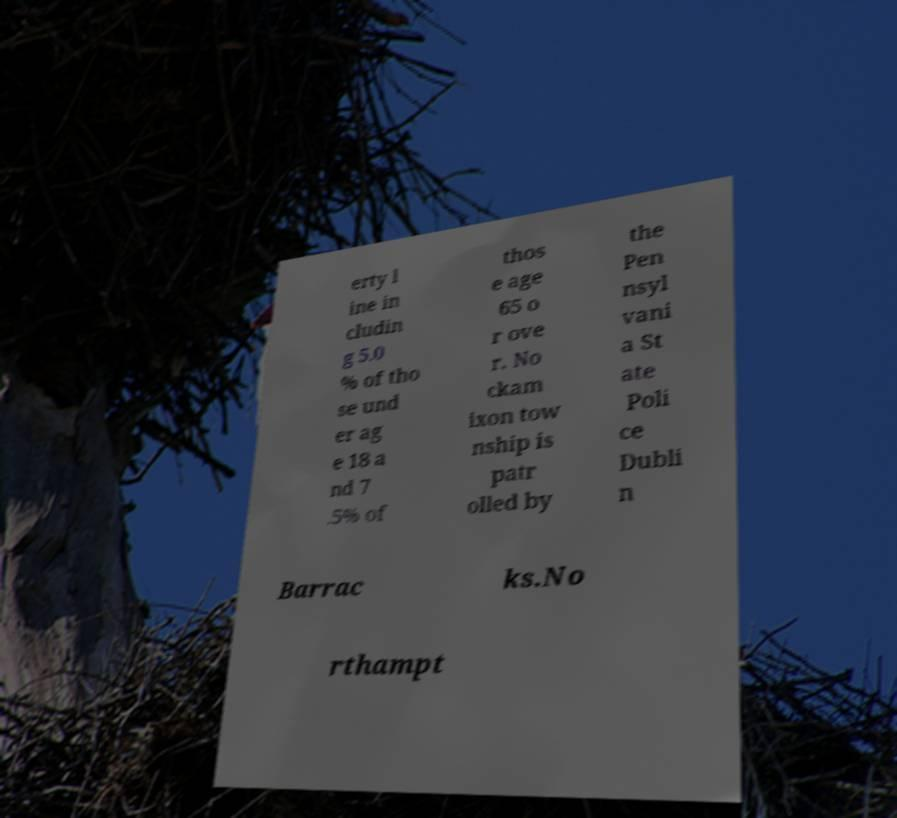I need the written content from this picture converted into text. Can you do that? erty l ine in cludin g 5.0 % of tho se und er ag e 18 a nd 7 .5% of thos e age 65 o r ove r. No ckam ixon tow nship is patr olled by the Pen nsyl vani a St ate Poli ce Dubli n Barrac ks.No rthampt 